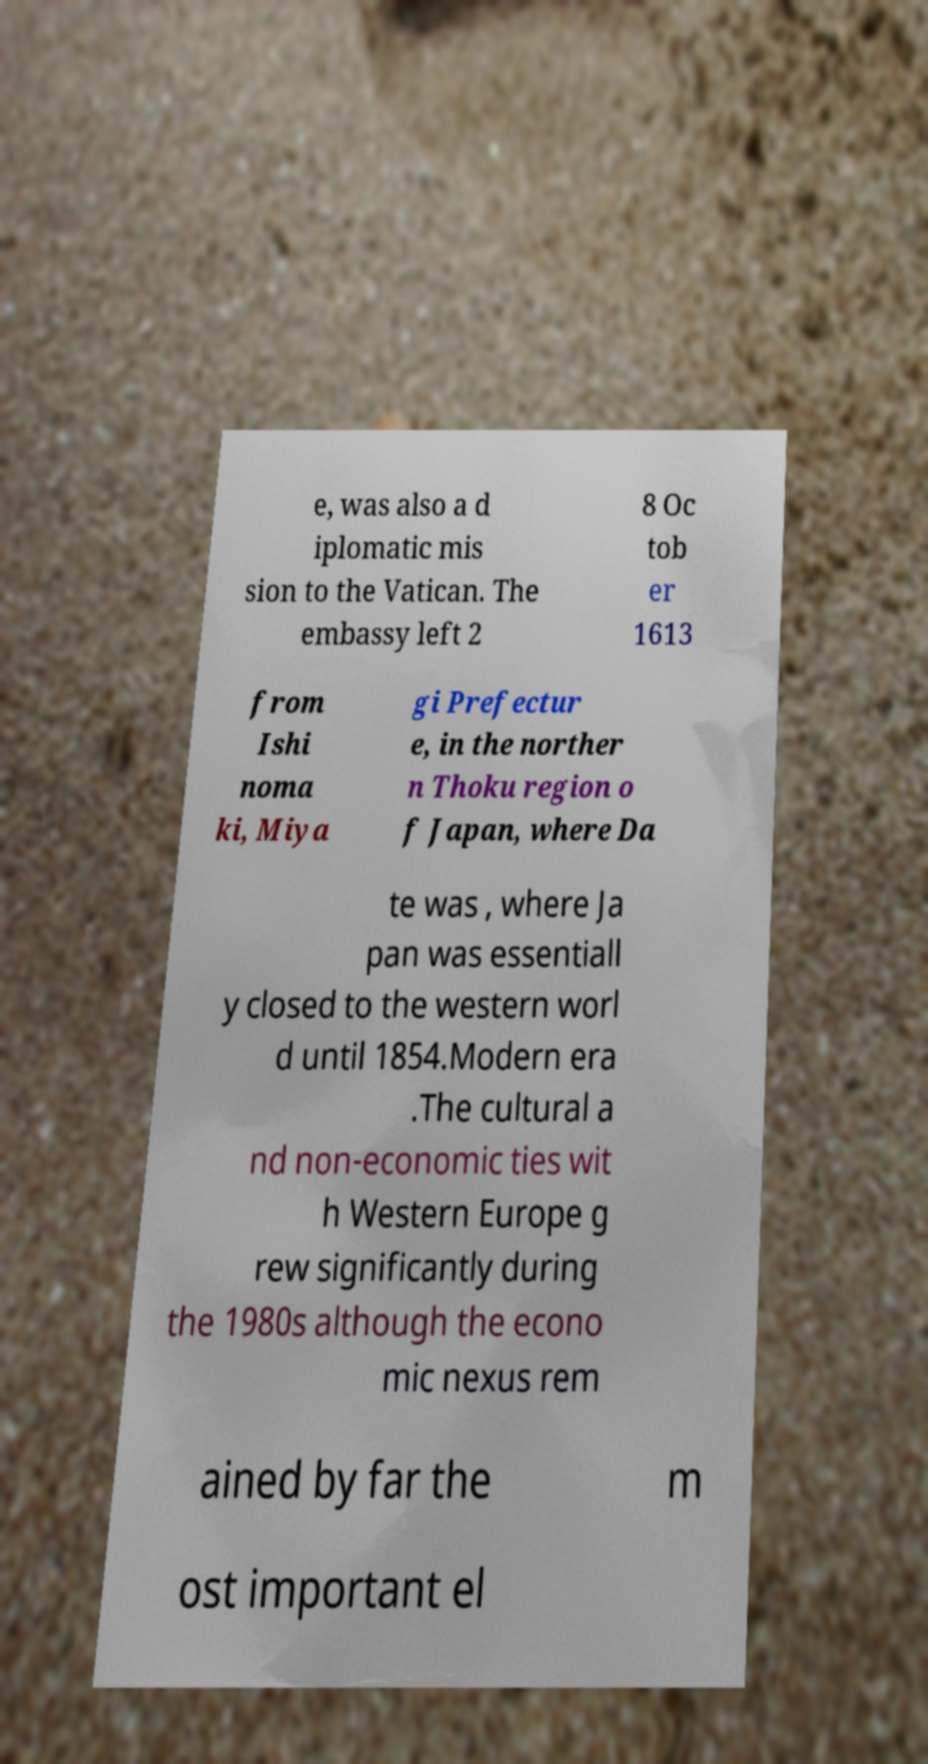I need the written content from this picture converted into text. Can you do that? e, was also a d iplomatic mis sion to the Vatican. The embassy left 2 8 Oc tob er 1613 from Ishi noma ki, Miya gi Prefectur e, in the norther n Thoku region o f Japan, where Da te was , where Ja pan was essentiall y closed to the western worl d until 1854.Modern era .The cultural a nd non-economic ties wit h Western Europe g rew significantly during the 1980s although the econo mic nexus rem ained by far the m ost important el 